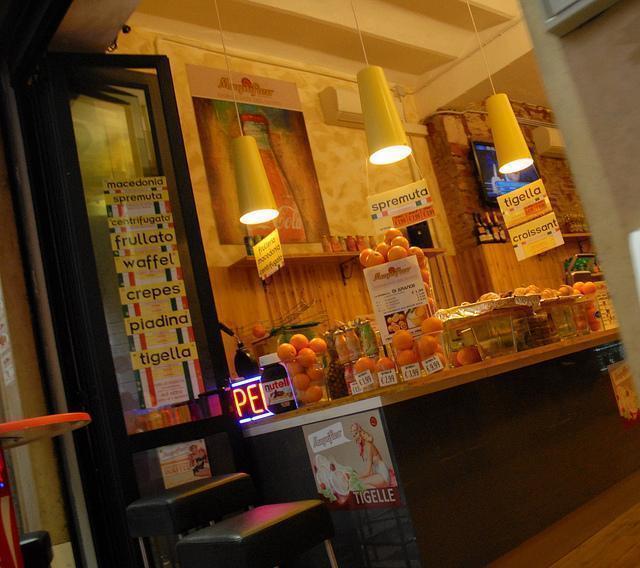What do people do here?
Select the accurate answer and provide explanation: 'Answer: answer
Rationale: rationale.'
Options: Swim, eat, gamble, drive. Answer: eat.
Rationale: People eat here. 